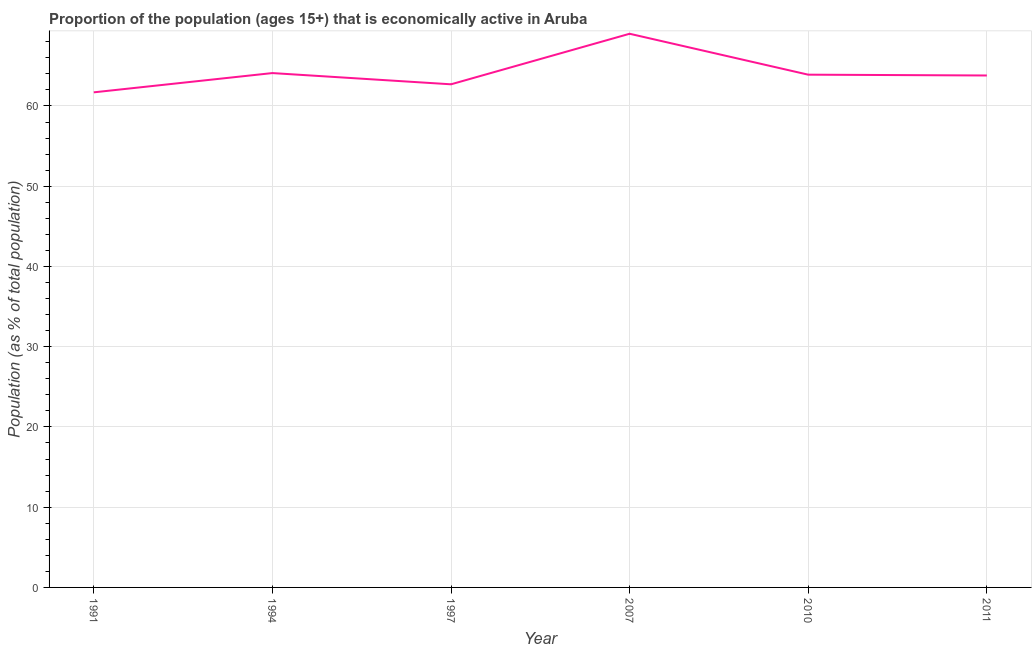What is the percentage of economically active population in 1994?
Make the answer very short. 64.1. Across all years, what is the minimum percentage of economically active population?
Make the answer very short. 61.7. What is the sum of the percentage of economically active population?
Keep it short and to the point. 385.2. What is the difference between the percentage of economically active population in 1997 and 2011?
Your response must be concise. -1.1. What is the average percentage of economically active population per year?
Offer a very short reply. 64.2. What is the median percentage of economically active population?
Keep it short and to the point. 63.85. In how many years, is the percentage of economically active population greater than 44 %?
Give a very brief answer. 6. What is the ratio of the percentage of economically active population in 1997 to that in 2011?
Your answer should be very brief. 0.98. Is the percentage of economically active population in 1997 less than that in 2007?
Your answer should be compact. Yes. Is the difference between the percentage of economically active population in 1994 and 2007 greater than the difference between any two years?
Your answer should be compact. No. What is the difference between the highest and the second highest percentage of economically active population?
Your response must be concise. 4.9. Is the sum of the percentage of economically active population in 1991 and 1994 greater than the maximum percentage of economically active population across all years?
Provide a short and direct response. Yes. What is the difference between the highest and the lowest percentage of economically active population?
Make the answer very short. 7.3. How many years are there in the graph?
Offer a terse response. 6. What is the difference between two consecutive major ticks on the Y-axis?
Offer a terse response. 10. Are the values on the major ticks of Y-axis written in scientific E-notation?
Give a very brief answer. No. What is the title of the graph?
Your answer should be very brief. Proportion of the population (ages 15+) that is economically active in Aruba. What is the label or title of the X-axis?
Keep it short and to the point. Year. What is the label or title of the Y-axis?
Your answer should be very brief. Population (as % of total population). What is the Population (as % of total population) of 1991?
Keep it short and to the point. 61.7. What is the Population (as % of total population) of 1994?
Keep it short and to the point. 64.1. What is the Population (as % of total population) in 1997?
Offer a very short reply. 62.7. What is the Population (as % of total population) in 2007?
Provide a succinct answer. 69. What is the Population (as % of total population) of 2010?
Your answer should be very brief. 63.9. What is the Population (as % of total population) of 2011?
Make the answer very short. 63.8. What is the difference between the Population (as % of total population) in 1991 and 1994?
Keep it short and to the point. -2.4. What is the difference between the Population (as % of total population) in 1991 and 1997?
Give a very brief answer. -1. What is the difference between the Population (as % of total population) in 1991 and 2011?
Provide a succinct answer. -2.1. What is the difference between the Population (as % of total population) in 1994 and 2010?
Your answer should be compact. 0.2. What is the difference between the Population (as % of total population) in 1997 and 2007?
Give a very brief answer. -6.3. What is the difference between the Population (as % of total population) in 1997 and 2011?
Keep it short and to the point. -1.1. What is the difference between the Population (as % of total population) in 2010 and 2011?
Provide a succinct answer. 0.1. What is the ratio of the Population (as % of total population) in 1991 to that in 1997?
Provide a short and direct response. 0.98. What is the ratio of the Population (as % of total population) in 1991 to that in 2007?
Provide a succinct answer. 0.89. What is the ratio of the Population (as % of total population) in 1991 to that in 2010?
Offer a terse response. 0.97. What is the ratio of the Population (as % of total population) in 1991 to that in 2011?
Keep it short and to the point. 0.97. What is the ratio of the Population (as % of total population) in 1994 to that in 1997?
Your answer should be very brief. 1.02. What is the ratio of the Population (as % of total population) in 1994 to that in 2007?
Ensure brevity in your answer.  0.93. What is the ratio of the Population (as % of total population) in 1994 to that in 2011?
Your response must be concise. 1. What is the ratio of the Population (as % of total population) in 1997 to that in 2007?
Provide a short and direct response. 0.91. What is the ratio of the Population (as % of total population) in 1997 to that in 2010?
Your answer should be compact. 0.98. What is the ratio of the Population (as % of total population) in 1997 to that in 2011?
Offer a very short reply. 0.98. What is the ratio of the Population (as % of total population) in 2007 to that in 2011?
Offer a terse response. 1.08. What is the ratio of the Population (as % of total population) in 2010 to that in 2011?
Offer a terse response. 1. 